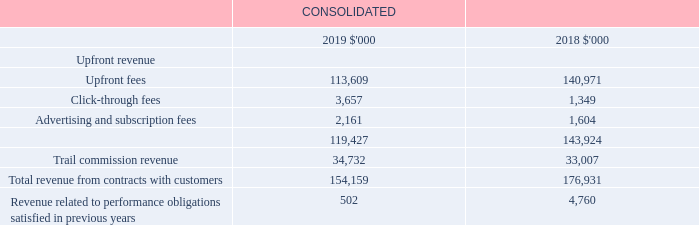2.2 Revenue from contracts with customers
Key estimate: upfront fee revenue
Upfront fee revenue is recognised on a net basis of the historical percentage of ‘referred’ sales expected to become ‘financial’ and that do not trigger a ‘clawback’. These estimates are adjusted to actual percentages experienced at each reporting date. As such, the Group determines its revenue by estimating variable consideration and applying the constraint by utilising industry data and historical experience (refer to note 3.6 for further information).
Key estimate: trail commission revenue
The method of revenue recognition for trail commission revenue requires Directors and management to make certain estimates and assumptions based on industry data and historical experience of the Group. Refer to note 3.4 for details on trail commission revenue.
Recognition and measurement
Revenue represents the variable consideration estimated at the point in time when the Group has essentially completed its contracted services and constrained until it is highly probable that a significant revenue reversal in the amount of cumulative revenue recognised will not occur when the associated uncertainty with the variable consideration is subsequently resolved.
Upfront fees
When the Group refers a consumer to the product provider (and thereby satisfies its performance obligation), the Group is entitled to an upfront fee that is contingent upon the following events: (a) the referred sale becoming ‘financial’, which occurs upon new members joining a health fund, initiating a life insurance policy, obtaining general insurance products, mortgages, broadband or energy products via iSelect; and (b) whether a ‘clawback’ of the upfront fee is triggered. Upfront fees may trigger a ‘clawback’ of revenue in the event of early termination by customers as specified in individual product provider agreements. These contingencies are incorporated into the estimate of variable consideration (refer to key estimates).
Click-through fees
Click-through fees are recognised based on the contractual arrangement with the relevant product provider. This can occur at one of three points; either when an internet user clicks on a paying advertiser’s link, submits an application or a submitted application is approved.
Advertising and subscription fees
Revenue for contracted services, including advertising and subscription fees, are recognised based on the transaction price allocated to each key performance obligation. As a result, non-refundable revenue may be recognised across multiple periods until the performance obligation has been satisfied.
Trail commission revenue
Trail commissions are ongoing fees for customers referred to individual product providers or who have applied for mortgages via iSelect. Trail commission revenue represents commission earned calculated as a percentage of the value of the underlying policy relationship to the expected life and, in the case of mortgages, a proportion of the underlying value of the loan. The Group is entitled to receive trail commission without having to perform further services. On initial recognition, trail revenue and assets are recognised at expected value and subject to constraints.
What are trial commissions? Ongoing fees for customers referred to individual product providers or who have applied for mortgages via iselect. How does the Group determine its revenue? By estimating variable consideration and applying the constraint by utilising industry data and historical experience. How are click-through fees recognised? Based on the contractual arrangement with the relevant product provider. What is the percentage change in upfront fees from 2018 to 2019?
Answer scale should be: percent. (113,609-140,971)/140,971
Answer: -19.41. What is the percentage change in click-through fees from 2018 to 2019?
Answer scale should be: percent. (3,657-1,349)/1,349
Answer: 171.09. What is the percentage change in the total upfront revenue from 2018 to 2019?
Answer scale should be: percent. (119,427-143,924)/143,924
Answer: -17.02. 